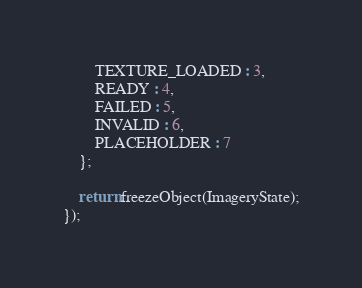<code> <loc_0><loc_0><loc_500><loc_500><_JavaScript_>        TEXTURE_LOADED : 3,
        READY : 4,
        FAILED : 5,
        INVALID : 6,
        PLACEHOLDER : 7
    };

    return freezeObject(ImageryState);
});
</code> 